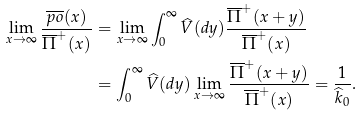Convert formula to latex. <formula><loc_0><loc_0><loc_500><loc_500>\lim _ { x \to \infty } \frac { \overline { p o } ( x ) } { \overline { \Pi } ^ { + } ( x ) } & = \lim _ { x \to \infty } \int ^ { \infty } _ { 0 } \widehat { V } ( d y ) \frac { \overline { \Pi } ^ { + } ( x + y ) } { \overline { \Pi } ^ { + } ( x ) } \\ & = \int ^ { \infty } _ { 0 } \widehat { V } ( d y ) \lim _ { x \to \infty } \frac { \overline { \Pi } ^ { + } ( x + y ) } { \overline { \Pi } ^ { + } ( x ) } = \frac { 1 } { \widehat { k } _ { 0 } } .</formula> 